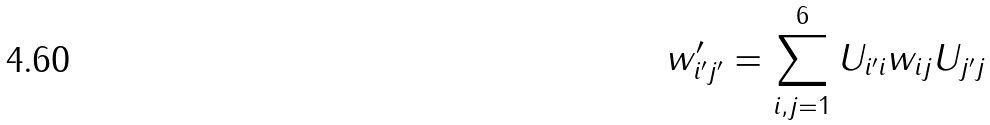<formula> <loc_0><loc_0><loc_500><loc_500>w ^ { \prime } _ { i ^ { \prime } j ^ { \prime } } = \sum _ { i , j = 1 } ^ { 6 } U _ { i ^ { \prime } i } w _ { i j } U _ { j ^ { \prime } j }</formula> 